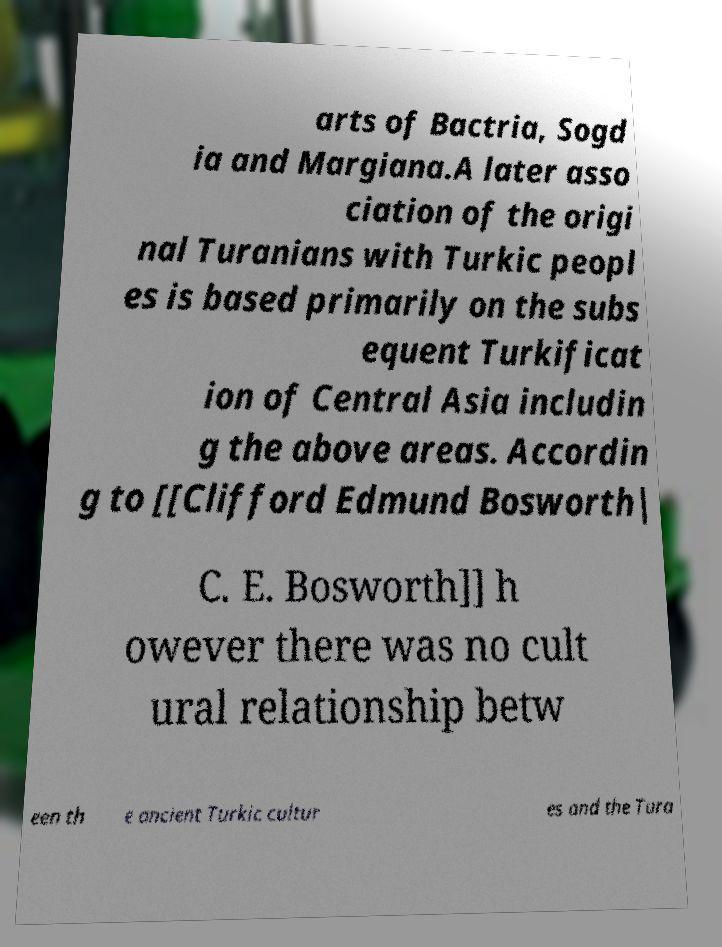Can you read and provide the text displayed in the image?This photo seems to have some interesting text. Can you extract and type it out for me? arts of Bactria, Sogd ia and Margiana.A later asso ciation of the origi nal Turanians with Turkic peopl es is based primarily on the subs equent Turkificat ion of Central Asia includin g the above areas. Accordin g to [[Clifford Edmund Bosworth| C. E. Bosworth]] h owever there was no cult ural relationship betw een th e ancient Turkic cultur es and the Tura 